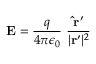Convert formula to latex. <formula><loc_0><loc_0><loc_500><loc_500>E = { \frac { q } { 4 \pi \epsilon _ { 0 } } } \ { \frac { { \hat { r } } ^ { \prime } } { | r ^ { \prime } | ^ { 2 } } }</formula> 